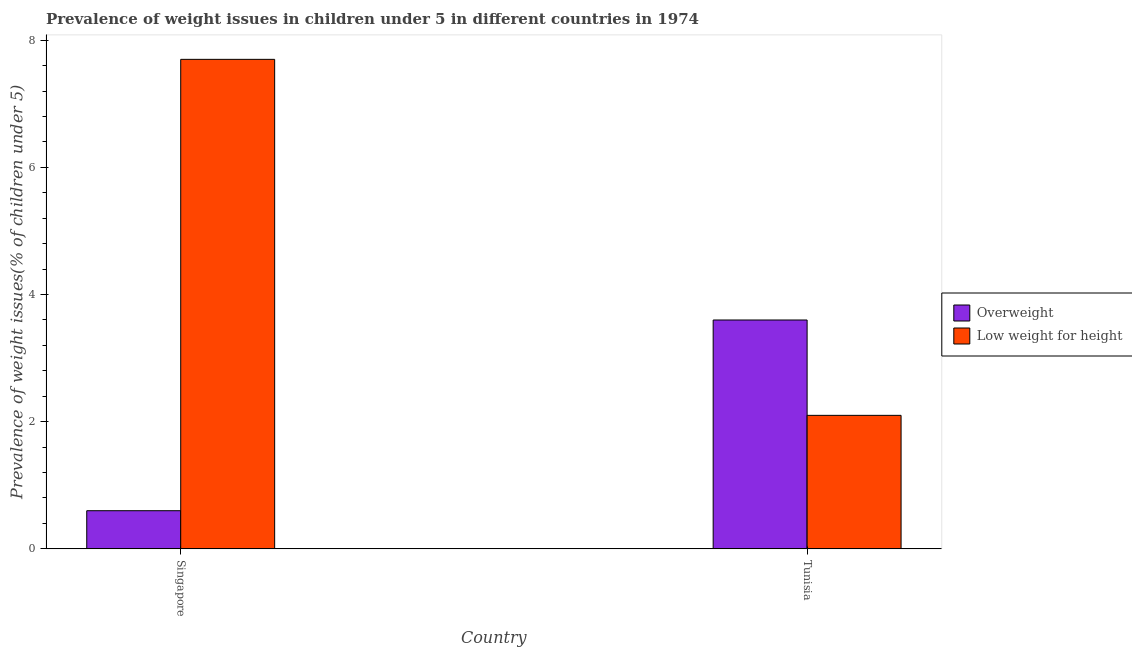How many different coloured bars are there?
Offer a very short reply. 2. How many groups of bars are there?
Ensure brevity in your answer.  2. Are the number of bars on each tick of the X-axis equal?
Ensure brevity in your answer.  Yes. How many bars are there on the 1st tick from the right?
Your answer should be compact. 2. What is the label of the 2nd group of bars from the left?
Give a very brief answer. Tunisia. What is the percentage of overweight children in Tunisia?
Make the answer very short. 3.6. Across all countries, what is the maximum percentage of underweight children?
Keep it short and to the point. 7.7. Across all countries, what is the minimum percentage of underweight children?
Your response must be concise. 2.1. In which country was the percentage of underweight children maximum?
Keep it short and to the point. Singapore. In which country was the percentage of overweight children minimum?
Your answer should be very brief. Singapore. What is the total percentage of overweight children in the graph?
Your response must be concise. 4.2. What is the difference between the percentage of underweight children in Singapore and that in Tunisia?
Offer a very short reply. 5.6. What is the difference between the percentage of underweight children in Tunisia and the percentage of overweight children in Singapore?
Ensure brevity in your answer.  1.5. What is the average percentage of overweight children per country?
Your answer should be very brief. 2.1. What is the difference between the percentage of overweight children and percentage of underweight children in Singapore?
Provide a short and direct response. -7.1. In how many countries, is the percentage of underweight children greater than 2.4 %?
Your response must be concise. 1. What is the ratio of the percentage of underweight children in Singapore to that in Tunisia?
Ensure brevity in your answer.  3.67. Is the percentage of underweight children in Singapore less than that in Tunisia?
Your response must be concise. No. What does the 1st bar from the left in Singapore represents?
Provide a short and direct response. Overweight. What does the 1st bar from the right in Singapore represents?
Your answer should be very brief. Low weight for height. How many bars are there?
Your response must be concise. 4. How many countries are there in the graph?
Your response must be concise. 2. What is the difference between two consecutive major ticks on the Y-axis?
Offer a very short reply. 2. Does the graph contain any zero values?
Your answer should be very brief. No. Where does the legend appear in the graph?
Offer a very short reply. Center right. What is the title of the graph?
Provide a succinct answer. Prevalence of weight issues in children under 5 in different countries in 1974. Does "Investment in Transport" appear as one of the legend labels in the graph?
Give a very brief answer. No. What is the label or title of the X-axis?
Provide a succinct answer. Country. What is the label or title of the Y-axis?
Provide a short and direct response. Prevalence of weight issues(% of children under 5). What is the Prevalence of weight issues(% of children under 5) of Overweight in Singapore?
Offer a very short reply. 0.6. What is the Prevalence of weight issues(% of children under 5) of Low weight for height in Singapore?
Offer a terse response. 7.7. What is the Prevalence of weight issues(% of children under 5) in Overweight in Tunisia?
Offer a very short reply. 3.6. What is the Prevalence of weight issues(% of children under 5) of Low weight for height in Tunisia?
Ensure brevity in your answer.  2.1. Across all countries, what is the maximum Prevalence of weight issues(% of children under 5) in Overweight?
Provide a succinct answer. 3.6. Across all countries, what is the maximum Prevalence of weight issues(% of children under 5) in Low weight for height?
Give a very brief answer. 7.7. Across all countries, what is the minimum Prevalence of weight issues(% of children under 5) in Overweight?
Provide a succinct answer. 0.6. Across all countries, what is the minimum Prevalence of weight issues(% of children under 5) in Low weight for height?
Your response must be concise. 2.1. What is the total Prevalence of weight issues(% of children under 5) in Low weight for height in the graph?
Provide a succinct answer. 9.8. What is the difference between the Prevalence of weight issues(% of children under 5) of Overweight in Singapore and that in Tunisia?
Make the answer very short. -3. What is the difference between the Prevalence of weight issues(% of children under 5) in Low weight for height in Singapore and that in Tunisia?
Give a very brief answer. 5.6. What is the difference between the Prevalence of weight issues(% of children under 5) in Overweight and Prevalence of weight issues(% of children under 5) in Low weight for height in Singapore?
Your answer should be very brief. -7.1. What is the ratio of the Prevalence of weight issues(% of children under 5) in Low weight for height in Singapore to that in Tunisia?
Your answer should be compact. 3.67. What is the difference between the highest and the second highest Prevalence of weight issues(% of children under 5) of Overweight?
Your answer should be compact. 3. What is the difference between the highest and the second highest Prevalence of weight issues(% of children under 5) in Low weight for height?
Keep it short and to the point. 5.6. What is the difference between the highest and the lowest Prevalence of weight issues(% of children under 5) of Overweight?
Offer a very short reply. 3. What is the difference between the highest and the lowest Prevalence of weight issues(% of children under 5) in Low weight for height?
Offer a terse response. 5.6. 